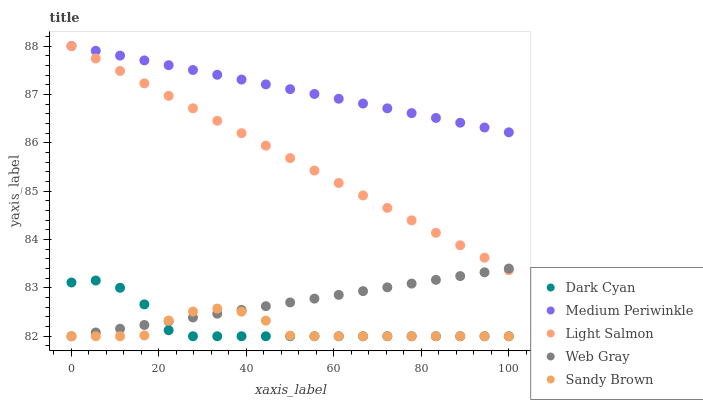Does Sandy Brown have the minimum area under the curve?
Answer yes or no. Yes. Does Medium Periwinkle have the maximum area under the curve?
Answer yes or no. Yes. Does Light Salmon have the minimum area under the curve?
Answer yes or no. No. Does Light Salmon have the maximum area under the curve?
Answer yes or no. No. Is Light Salmon the smoothest?
Answer yes or no. Yes. Is Sandy Brown the roughest?
Answer yes or no. Yes. Is Sandy Brown the smoothest?
Answer yes or no. No. Is Light Salmon the roughest?
Answer yes or no. No. Does Dark Cyan have the lowest value?
Answer yes or no. Yes. Does Light Salmon have the lowest value?
Answer yes or no. No. Does Medium Periwinkle have the highest value?
Answer yes or no. Yes. Does Sandy Brown have the highest value?
Answer yes or no. No. Is Dark Cyan less than Medium Periwinkle?
Answer yes or no. Yes. Is Medium Periwinkle greater than Sandy Brown?
Answer yes or no. Yes. Does Sandy Brown intersect Dark Cyan?
Answer yes or no. Yes. Is Sandy Brown less than Dark Cyan?
Answer yes or no. No. Is Sandy Brown greater than Dark Cyan?
Answer yes or no. No. Does Dark Cyan intersect Medium Periwinkle?
Answer yes or no. No. 